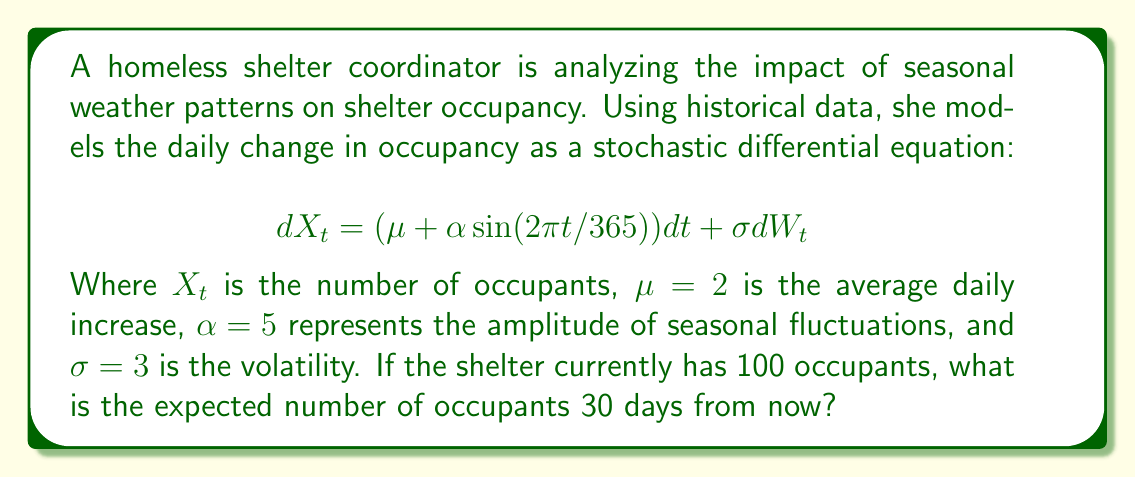Help me with this question. To solve this problem, we need to follow these steps:

1) The given stochastic differential equation is of the form:
   $$dX_t = a(t, X_t)dt + b(t, X_t)dW_t$$
   
   Where $a(t, X_t) = \mu + \alpha \sin(2\pi t/365)$ and $b(t, X_t) = \sigma$

2) For this type of SDE, the expected value of $X_t$ satisfies the ordinary differential equation:
   $$\frac{d}{dt}E[X_t] = E[a(t, X_t)]$$

3) In our case, this becomes:
   $$\frac{d}{dt}E[X_t] = \mu + \alpha \sin(2\pi t/365)$$

4) Integrating both sides from 0 to 30:
   $$E[X_{30}] - E[X_0] = \int_0^{30} (\mu + \alpha \sin(2\pi t/365))dt$$

5) Solving the integral:
   $$E[X_{30}] - E[X_0] = \mu t - \frac{365\alpha}{2\pi} \cos(2\pi t/365) \bigg|_0^{30}$$
   
   $$= 30\mu - \frac{365\alpha}{2\pi} [\cos(2\pi \cdot 30/365) - 1]$$

6) Substituting the given values:
   $$E[X_{30}] - 100 = 30 \cdot 2 - \frac{365 \cdot 5}{2\pi} [\cos(2\pi \cdot 30/365) - 1]$$
   
   $$= 60 - 290.84 [\cos(0.5165) - 1]$$
   
   $$= 60 - 290.84 [0.8684 - 1]$$
   
   $$= 60 + 38.24 = 98.24$$

7) Therefore, $E[X_{30}] = 100 + 98.24 = 198.24$
Answer: 198 occupants (rounded to the nearest whole number) 